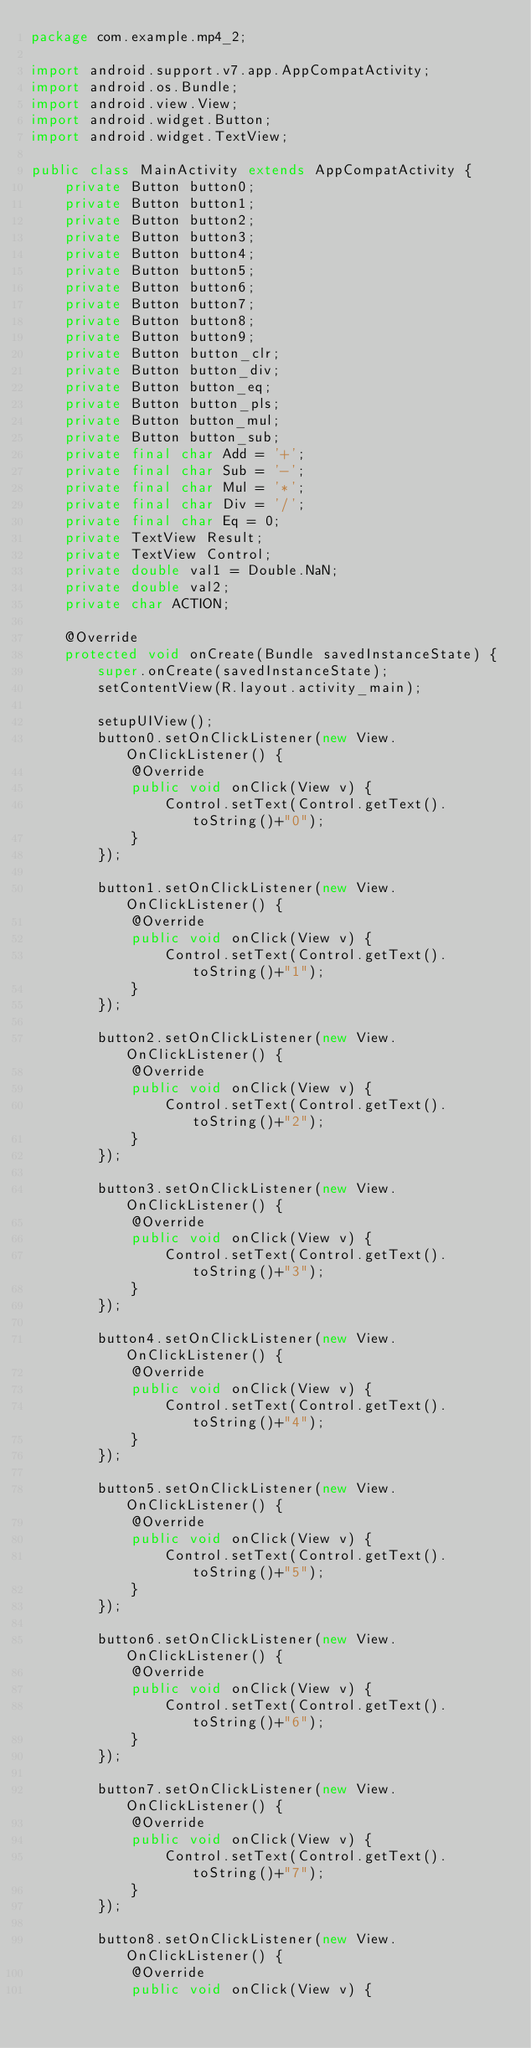<code> <loc_0><loc_0><loc_500><loc_500><_Java_>package com.example.mp4_2;

import android.support.v7.app.AppCompatActivity;
import android.os.Bundle;
import android.view.View;
import android.widget.Button;
import android.widget.TextView;

public class MainActivity extends AppCompatActivity {
    private Button button0;
    private Button button1;
    private Button button2;
    private Button button3;
    private Button button4;
    private Button button5;
    private Button button6;
    private Button button7;
    private Button button8;
    private Button button9;
    private Button button_clr;
    private Button button_div;
    private Button button_eq;
    private Button button_pls;
    private Button button_mul;
    private Button button_sub;
    private final char Add = '+';
    private final char Sub = '-';
    private final char Mul = '*';
    private final char Div = '/';
    private final char Eq = 0;
    private TextView Result;
    private TextView Control;
    private double val1 = Double.NaN;
    private double val2;
    private char ACTION;

    @Override
    protected void onCreate(Bundle savedInstanceState) {
        super.onCreate(savedInstanceState);
        setContentView(R.layout.activity_main);

        setupUIView();
        button0.setOnClickListener(new View.OnClickListener() {
            @Override
            public void onClick(View v) {
                Control.setText(Control.getText().toString()+"0");
            }
        });

        button1.setOnClickListener(new View.OnClickListener() {
            @Override
            public void onClick(View v) {
                Control.setText(Control.getText().toString()+"1");
            }
        });

        button2.setOnClickListener(new View.OnClickListener() {
            @Override
            public void onClick(View v) {
                Control.setText(Control.getText().toString()+"2");
            }
        });

        button3.setOnClickListener(new View.OnClickListener() {
            @Override
            public void onClick(View v) {
                Control.setText(Control.getText().toString()+"3");
            }
        });

        button4.setOnClickListener(new View.OnClickListener() {
            @Override
            public void onClick(View v) {
                Control.setText(Control.getText().toString()+"4");
            }
        });

        button5.setOnClickListener(new View.OnClickListener() {
            @Override
            public void onClick(View v) {
                Control.setText(Control.getText().toString()+"5");
            }
        });

        button6.setOnClickListener(new View.OnClickListener() {
            @Override
            public void onClick(View v) {
                Control.setText(Control.getText().toString()+"6");
            }
        });

        button7.setOnClickListener(new View.OnClickListener() {
            @Override
            public void onClick(View v) {
                Control.setText(Control.getText().toString()+"7");
            }
        });

        button8.setOnClickListener(new View.OnClickListener() {
            @Override
            public void onClick(View v) {</code> 